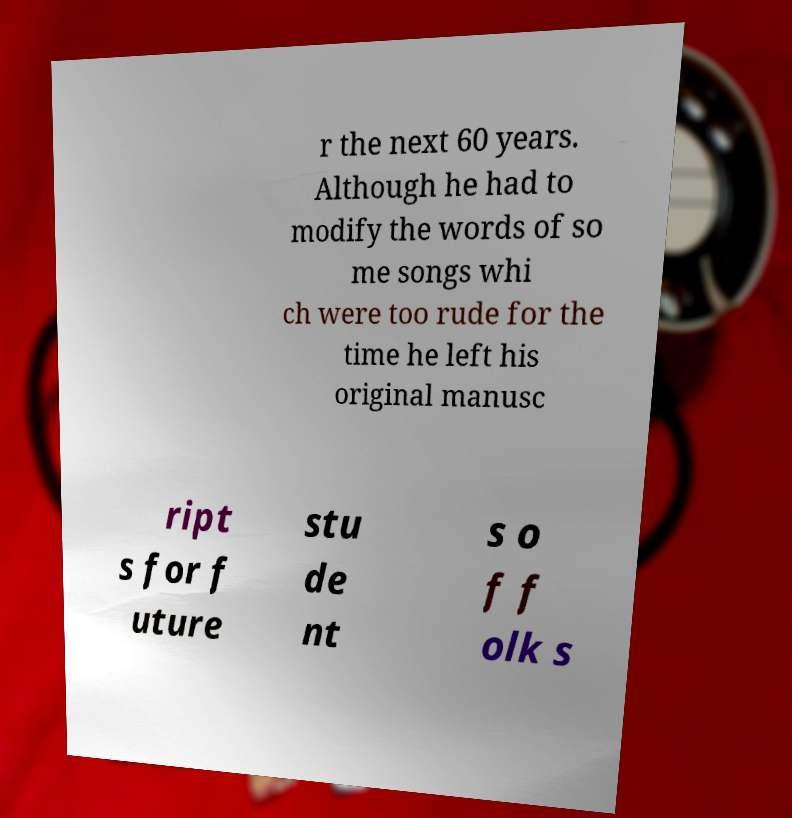Please read and relay the text visible in this image. What does it say? r the next 60 years. Although he had to modify the words of so me songs whi ch were too rude for the time he left his original manusc ript s for f uture stu de nt s o f f olk s 